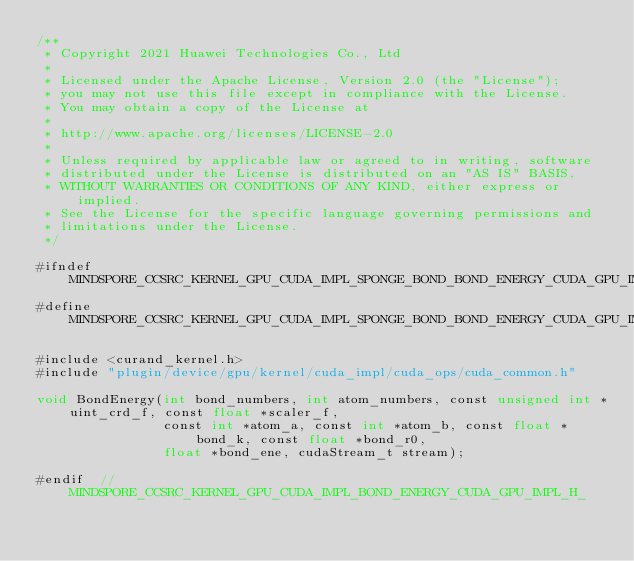Convert code to text. <code><loc_0><loc_0><loc_500><loc_500><_Cuda_>/**
 * Copyright 2021 Huawei Technologies Co., Ltd
 *
 * Licensed under the Apache License, Version 2.0 (the "License");
 * you may not use this file except in compliance with the License.
 * You may obtain a copy of the License at
 *
 * http://www.apache.org/licenses/LICENSE-2.0
 *
 * Unless required by applicable law or agreed to in writing, software
 * distributed under the License is distributed on an "AS IS" BASIS,
 * WITHOUT WARRANTIES OR CONDITIONS OF ANY KIND, either express or implied.
 * See the License for the specific language governing permissions and
 * limitations under the License.
 */

#ifndef MINDSPORE_CCSRC_KERNEL_GPU_CUDA_IMPL_SPONGE_BOND_BOND_ENERGY_CUDA_GPU_IMPL_H_
#define MINDSPORE_CCSRC_KERNEL_GPU_CUDA_IMPL_SPONGE_BOND_BOND_ENERGY_CUDA_GPU_IMPL_H_

#include <curand_kernel.h>
#include "plugin/device/gpu/kernel/cuda_impl/cuda_ops/cuda_common.h"

void BondEnergy(int bond_numbers, int atom_numbers, const unsigned int *uint_crd_f, const float *scaler_f,
                const int *atom_a, const int *atom_b, const float *bond_k, const float *bond_r0,
                float *bond_ene, cudaStream_t stream);

#endif  // MINDSPORE_CCSRC_KERNEL_GPU_CUDA_IMPL_BOND_ENERGY_CUDA_GPU_IMPL_H_
</code> 